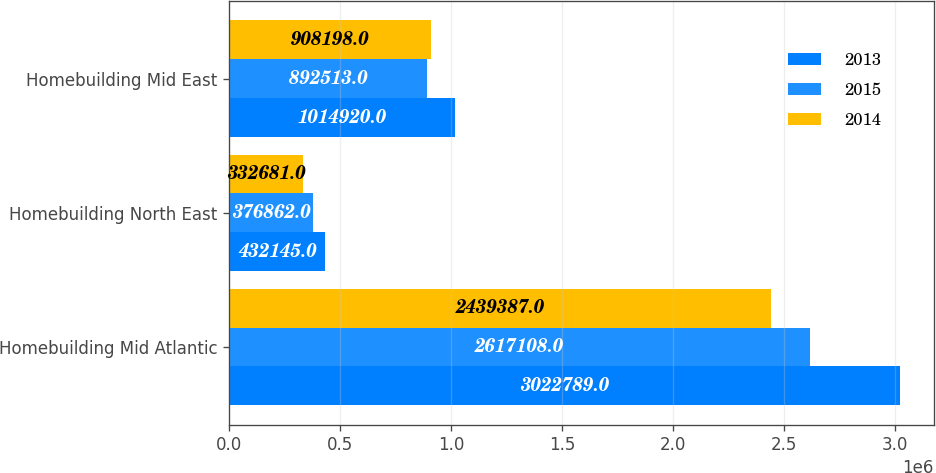<chart> <loc_0><loc_0><loc_500><loc_500><stacked_bar_chart><ecel><fcel>Homebuilding Mid Atlantic<fcel>Homebuilding North East<fcel>Homebuilding Mid East<nl><fcel>2013<fcel>3.02279e+06<fcel>432145<fcel>1.01492e+06<nl><fcel>2015<fcel>2.61711e+06<fcel>376862<fcel>892513<nl><fcel>2014<fcel>2.43939e+06<fcel>332681<fcel>908198<nl></chart> 